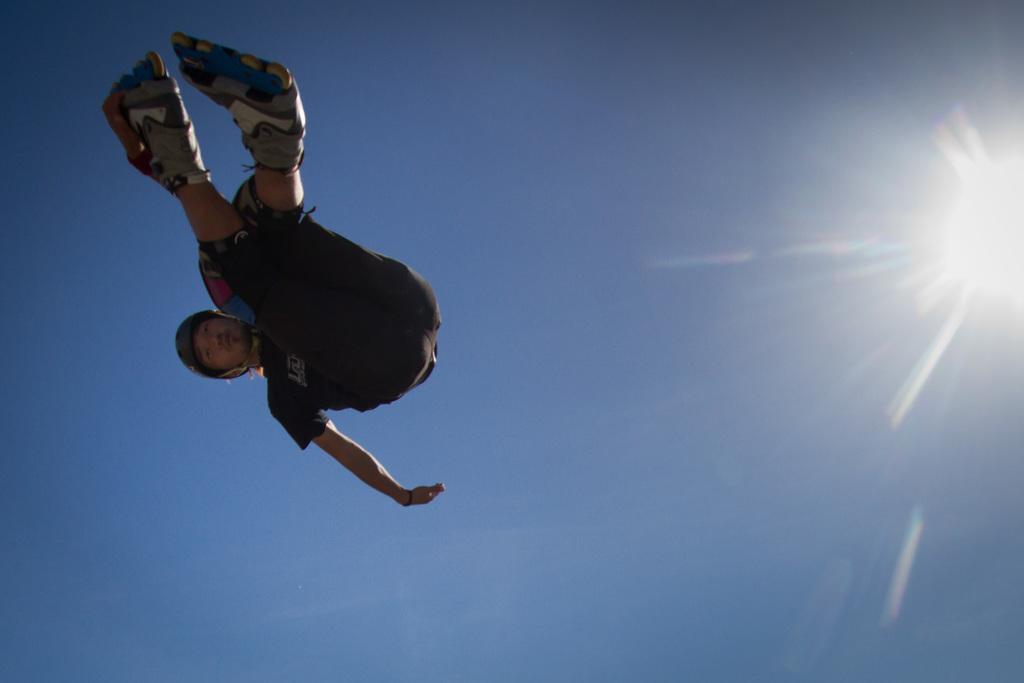Who or what is the main subject in the image? There is a person in the image. What is the person doing in the image? The person is jumping in the sky. What can be seen in the background of the image? There is bright sunshine in the background of the image. What type of field is visible in the image? There is no field visible in the image; it features a person jumping in the sky with bright sunshine in the background. 